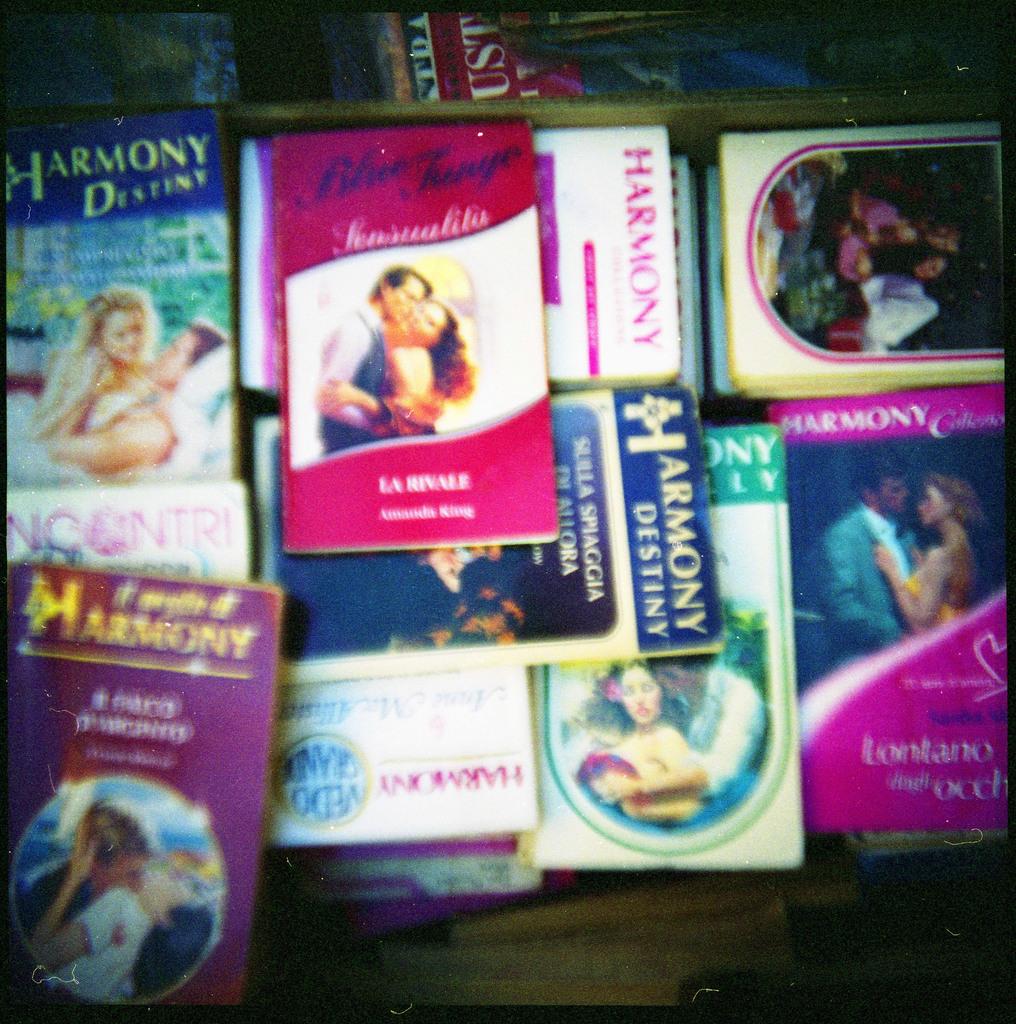What is the common name on all the books?
Offer a terse response. Harmony. Who wrote the book in the middle that is in pink?
Ensure brevity in your answer.  Amanda king. 